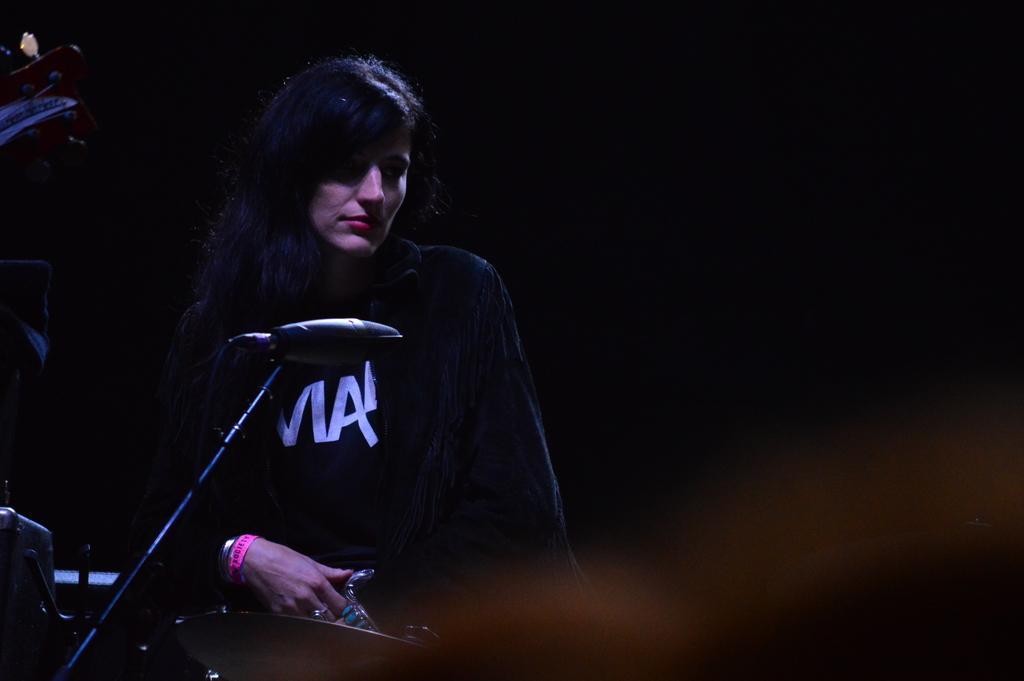In one or two sentences, can you explain what this image depicts? In this image there is a woman sitting on a chair and in front of her there is mike and some musical instruments. 